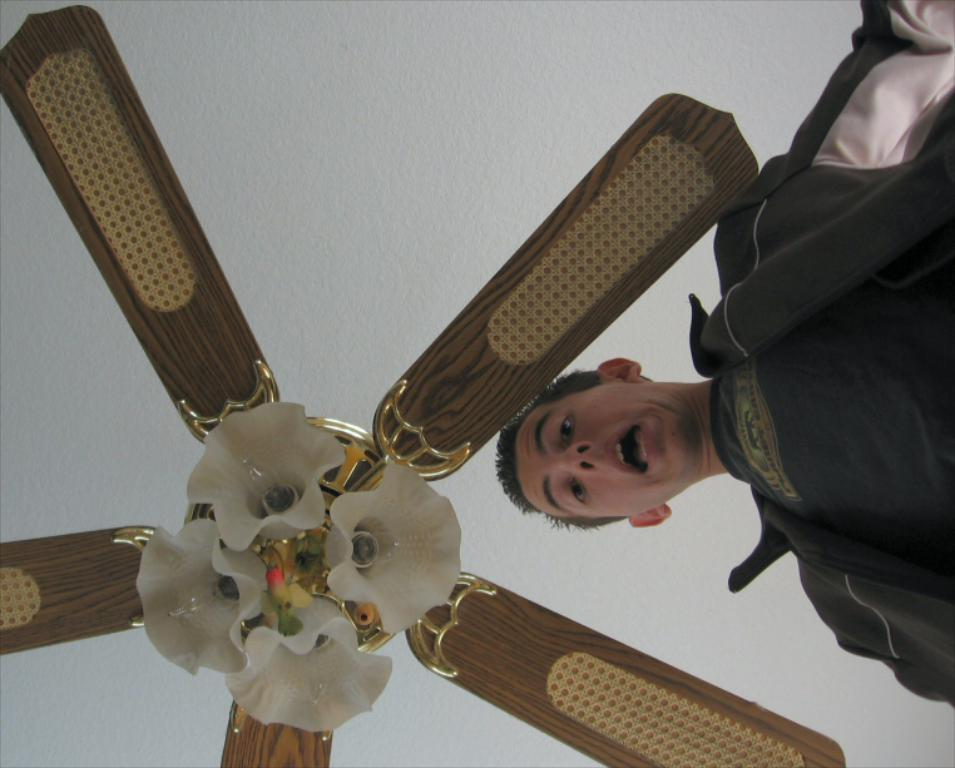Who is present in the image? There is a man in the image. What is the man doing in the image? The man is looking downwards. What can be seen above the man in the image? There is a fan above the man in the image. How many pizzas are on the bed in the image? There is no bed or pizzas present in the image. 